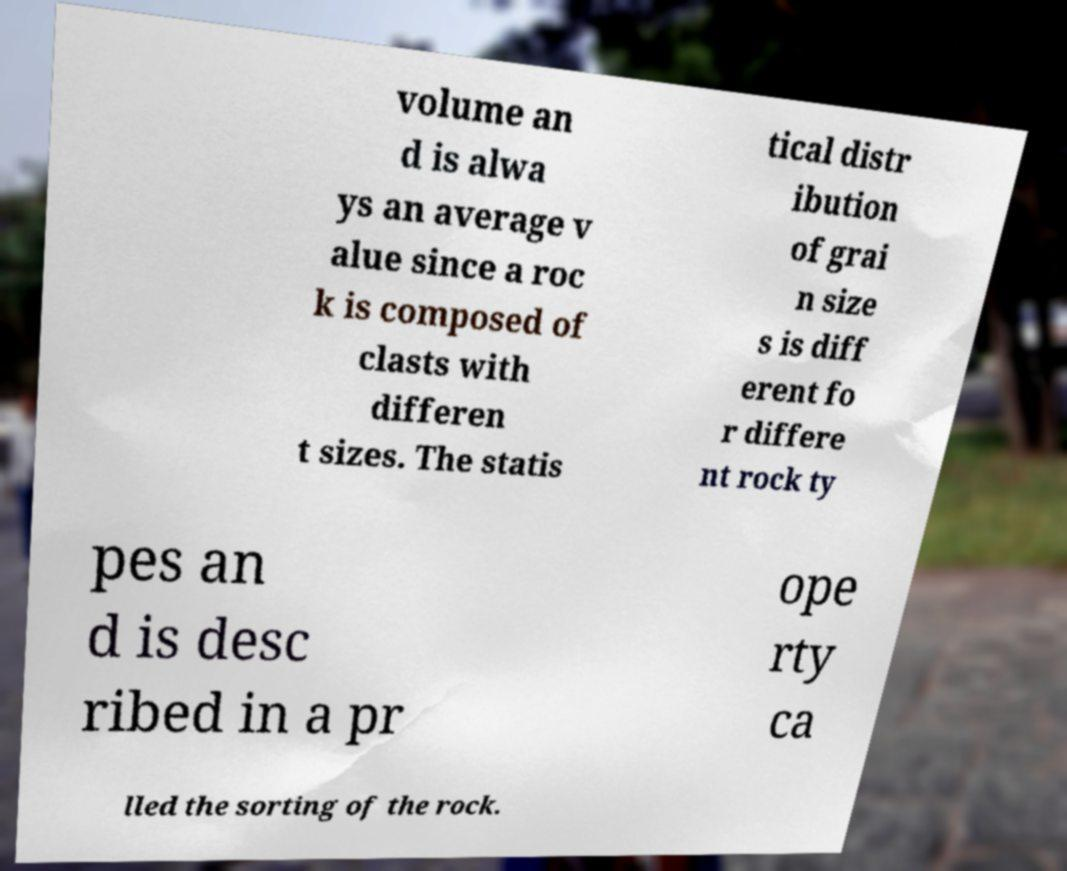Could you extract and type out the text from this image? volume an d is alwa ys an average v alue since a roc k is composed of clasts with differen t sizes. The statis tical distr ibution of grai n size s is diff erent fo r differe nt rock ty pes an d is desc ribed in a pr ope rty ca lled the sorting of the rock. 